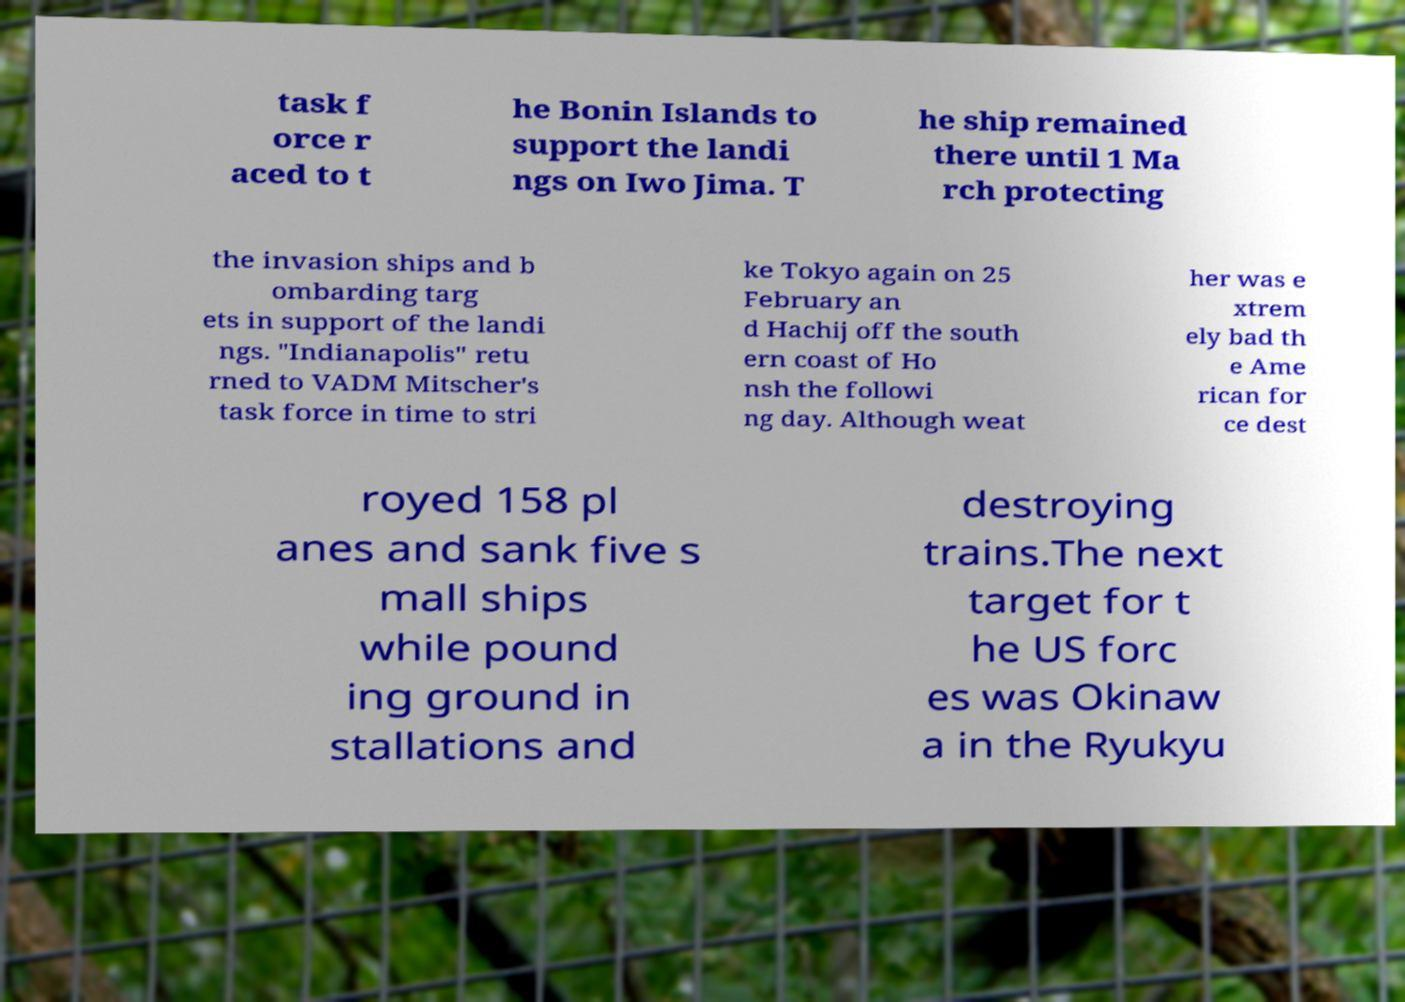Please read and relay the text visible in this image. What does it say? task f orce r aced to t he Bonin Islands to support the landi ngs on Iwo Jima. T he ship remained there until 1 Ma rch protecting the invasion ships and b ombarding targ ets in support of the landi ngs. "Indianapolis" retu rned to VADM Mitscher's task force in time to stri ke Tokyo again on 25 February an d Hachij off the south ern coast of Ho nsh the followi ng day. Although weat her was e xtrem ely bad th e Ame rican for ce dest royed 158 pl anes and sank five s mall ships while pound ing ground in stallations and destroying trains.The next target for t he US forc es was Okinaw a in the Ryukyu 